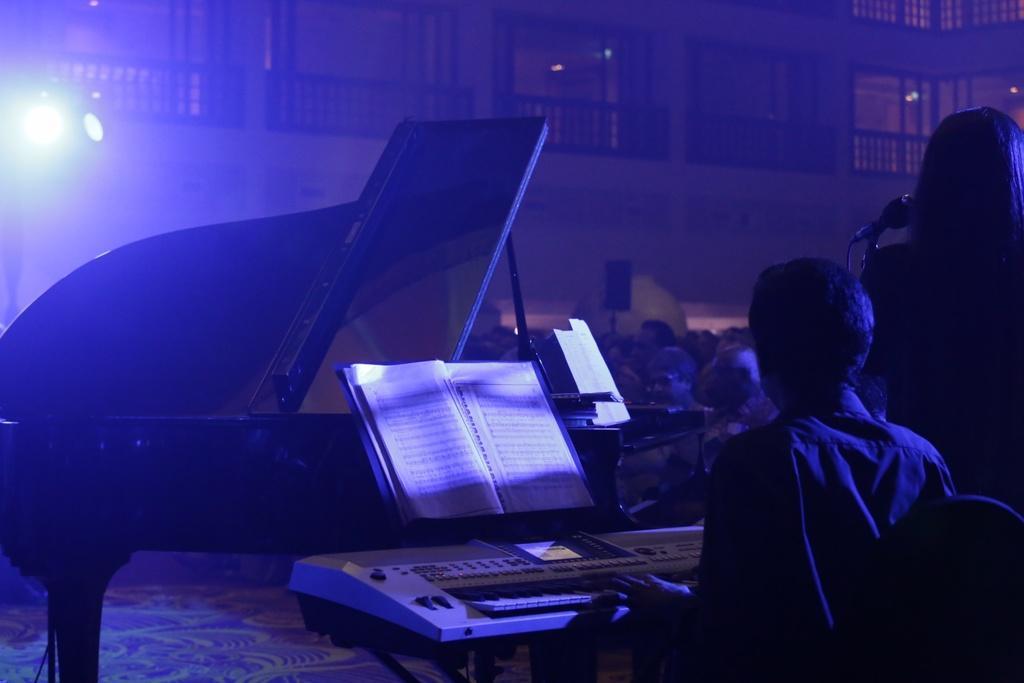How would you summarize this image in a sentence or two? This woman is standing in-front of mic. This man is playing piano keyboard. In-front of this piano keyboard there is a book. These are audience. 